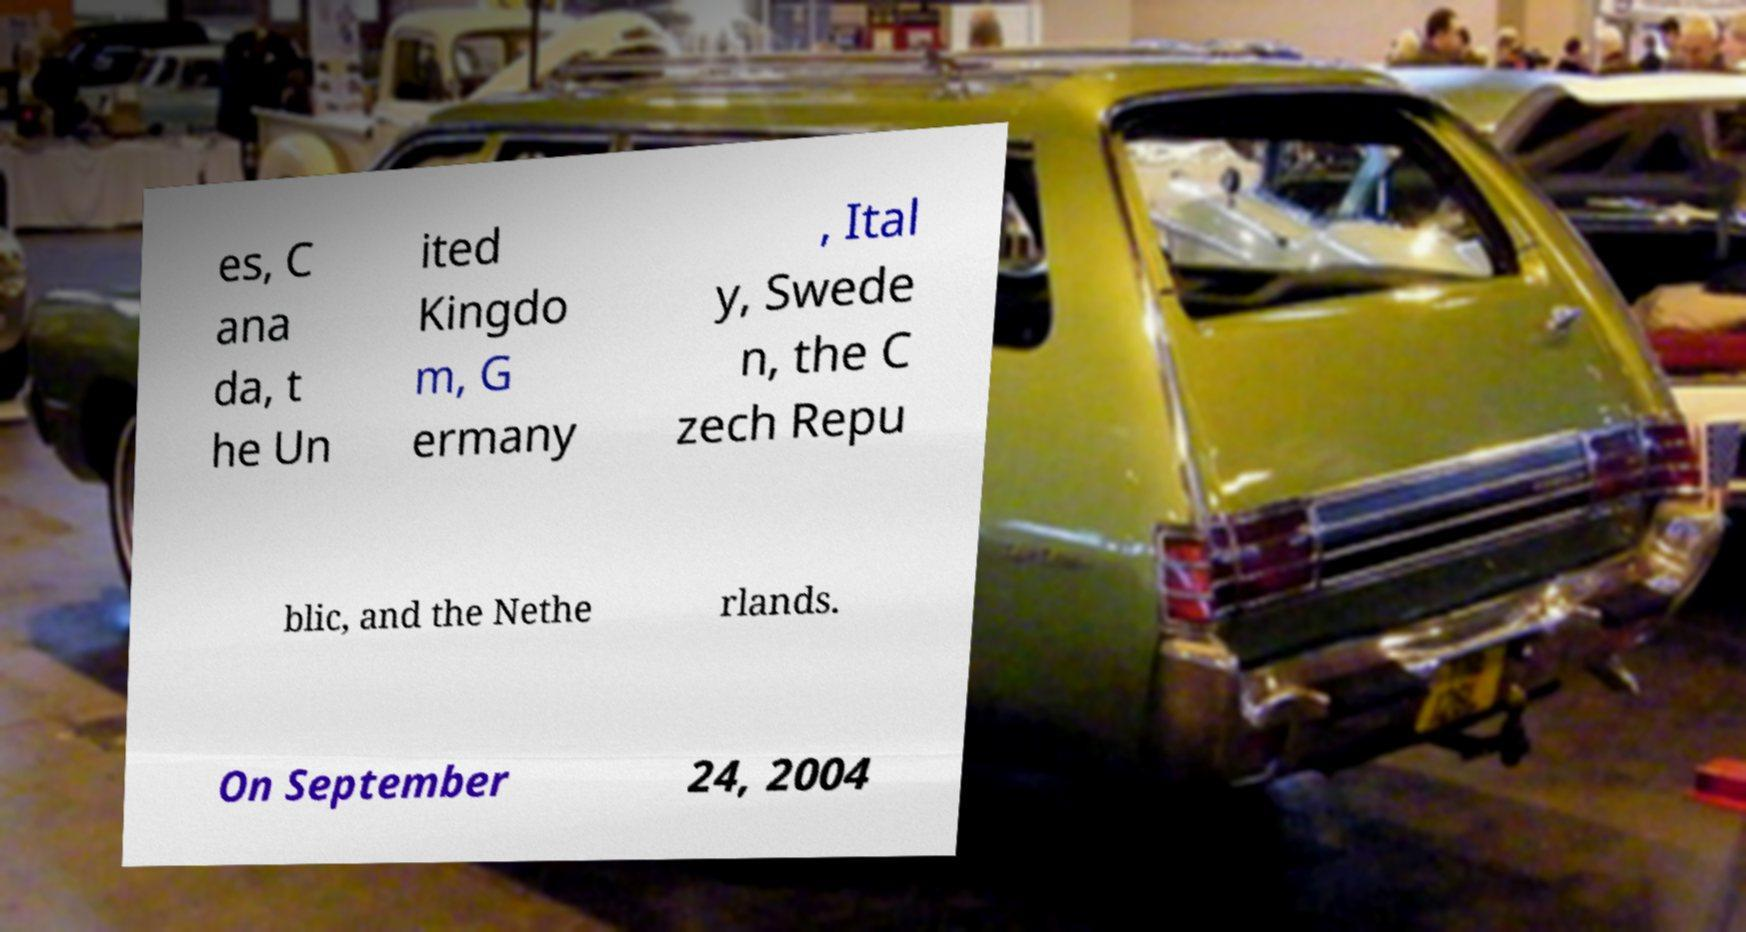Could you assist in decoding the text presented in this image and type it out clearly? es, C ana da, t he Un ited Kingdo m, G ermany , Ital y, Swede n, the C zech Repu blic, and the Nethe rlands. On September 24, 2004 